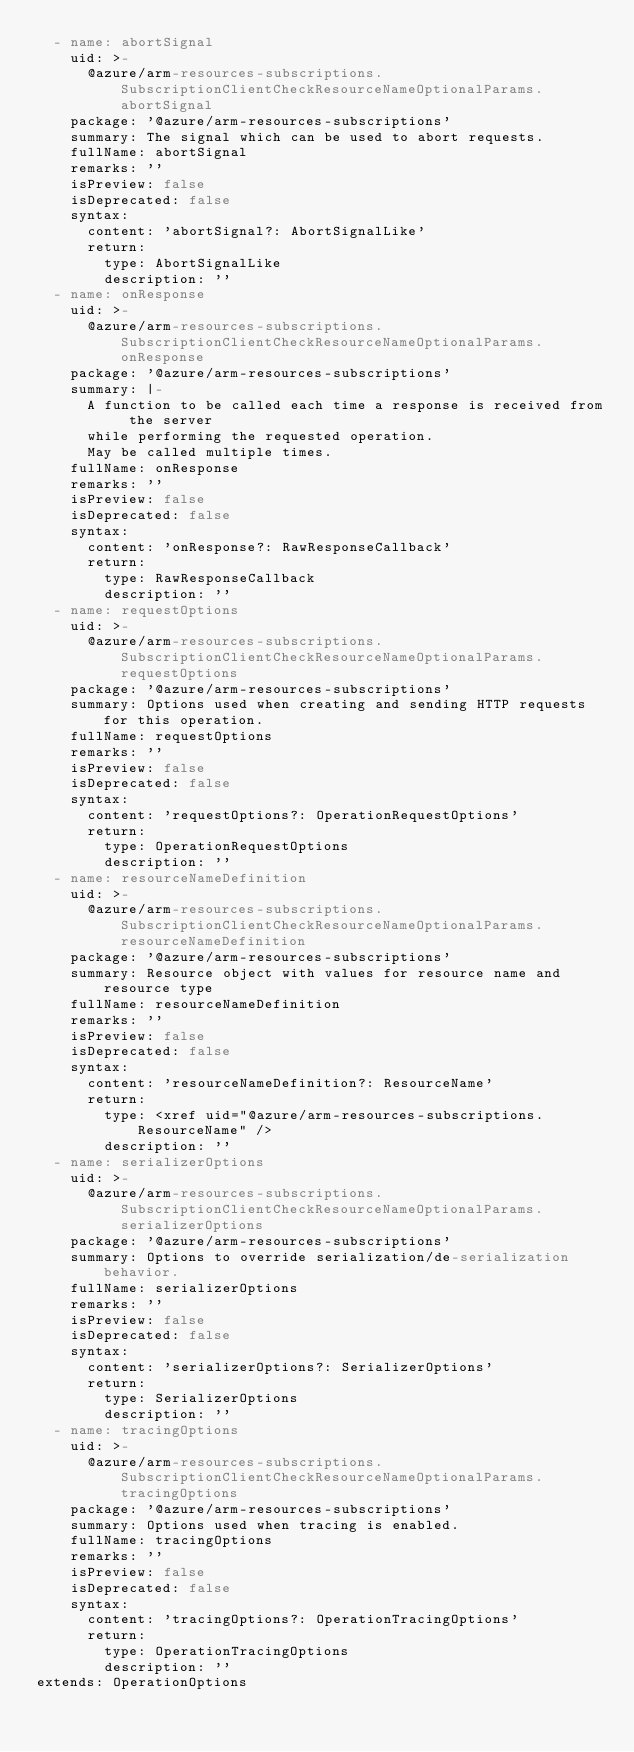<code> <loc_0><loc_0><loc_500><loc_500><_YAML_>  - name: abortSignal
    uid: >-
      @azure/arm-resources-subscriptions.SubscriptionClientCheckResourceNameOptionalParams.abortSignal
    package: '@azure/arm-resources-subscriptions'
    summary: The signal which can be used to abort requests.
    fullName: abortSignal
    remarks: ''
    isPreview: false
    isDeprecated: false
    syntax:
      content: 'abortSignal?: AbortSignalLike'
      return:
        type: AbortSignalLike
        description: ''
  - name: onResponse
    uid: >-
      @azure/arm-resources-subscriptions.SubscriptionClientCheckResourceNameOptionalParams.onResponse
    package: '@azure/arm-resources-subscriptions'
    summary: |-
      A function to be called each time a response is received from the server
      while performing the requested operation.
      May be called multiple times.
    fullName: onResponse
    remarks: ''
    isPreview: false
    isDeprecated: false
    syntax:
      content: 'onResponse?: RawResponseCallback'
      return:
        type: RawResponseCallback
        description: ''
  - name: requestOptions
    uid: >-
      @azure/arm-resources-subscriptions.SubscriptionClientCheckResourceNameOptionalParams.requestOptions
    package: '@azure/arm-resources-subscriptions'
    summary: Options used when creating and sending HTTP requests for this operation.
    fullName: requestOptions
    remarks: ''
    isPreview: false
    isDeprecated: false
    syntax:
      content: 'requestOptions?: OperationRequestOptions'
      return:
        type: OperationRequestOptions
        description: ''
  - name: resourceNameDefinition
    uid: >-
      @azure/arm-resources-subscriptions.SubscriptionClientCheckResourceNameOptionalParams.resourceNameDefinition
    package: '@azure/arm-resources-subscriptions'
    summary: Resource object with values for resource name and resource type
    fullName: resourceNameDefinition
    remarks: ''
    isPreview: false
    isDeprecated: false
    syntax:
      content: 'resourceNameDefinition?: ResourceName'
      return:
        type: <xref uid="@azure/arm-resources-subscriptions.ResourceName" />
        description: ''
  - name: serializerOptions
    uid: >-
      @azure/arm-resources-subscriptions.SubscriptionClientCheckResourceNameOptionalParams.serializerOptions
    package: '@azure/arm-resources-subscriptions'
    summary: Options to override serialization/de-serialization behavior.
    fullName: serializerOptions
    remarks: ''
    isPreview: false
    isDeprecated: false
    syntax:
      content: 'serializerOptions?: SerializerOptions'
      return:
        type: SerializerOptions
        description: ''
  - name: tracingOptions
    uid: >-
      @azure/arm-resources-subscriptions.SubscriptionClientCheckResourceNameOptionalParams.tracingOptions
    package: '@azure/arm-resources-subscriptions'
    summary: Options used when tracing is enabled.
    fullName: tracingOptions
    remarks: ''
    isPreview: false
    isDeprecated: false
    syntax:
      content: 'tracingOptions?: OperationTracingOptions'
      return:
        type: OperationTracingOptions
        description: ''
extends: OperationOptions
</code> 